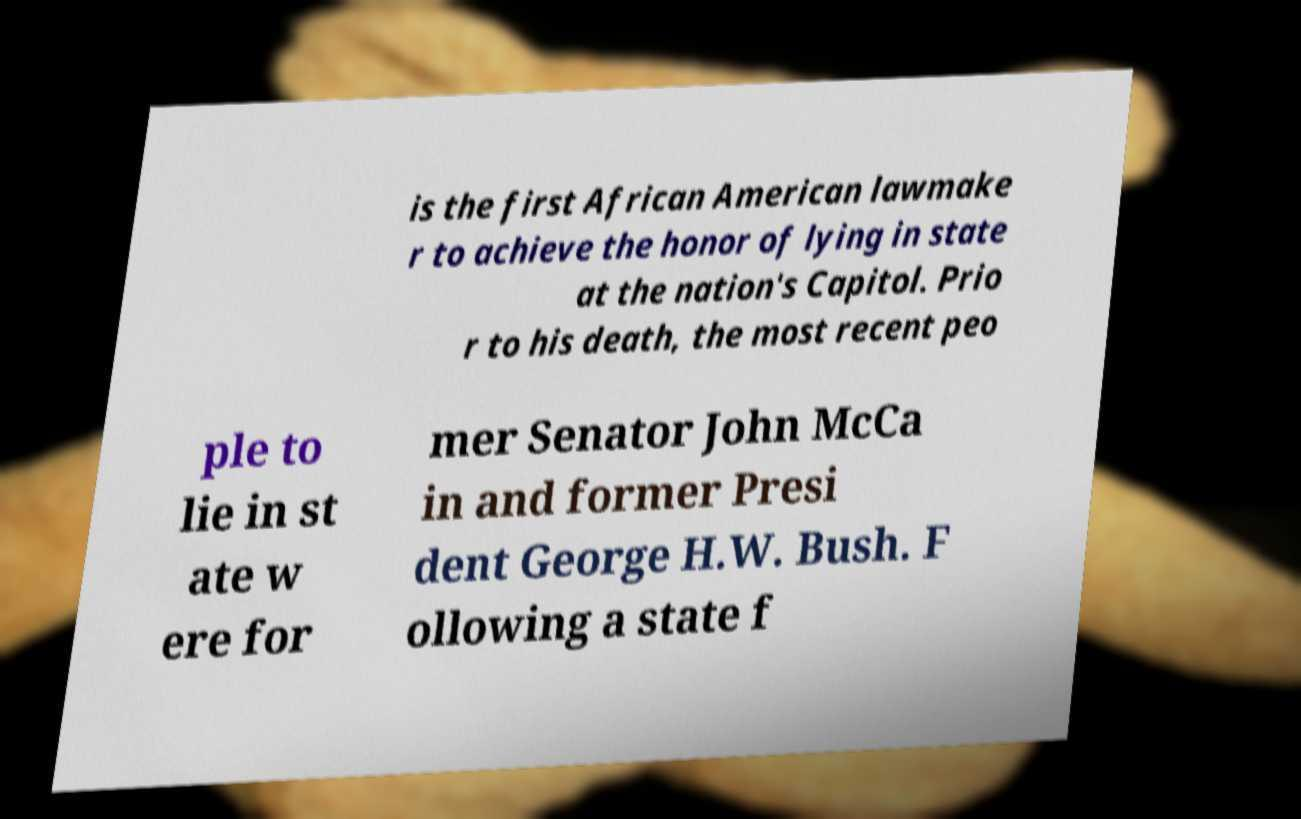Please identify and transcribe the text found in this image. is the first African American lawmake r to achieve the honor of lying in state at the nation's Capitol. Prio r to his death, the most recent peo ple to lie in st ate w ere for mer Senator John McCa in and former Presi dent George H.W. Bush. F ollowing a state f 